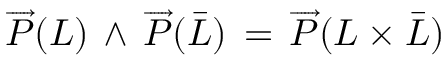<formula> <loc_0><loc_0><loc_500><loc_500>\overrightarrow { P } ( L ) \, \wedge \, \overrightarrow { P } ( \bar { L } ) \, = \, \overrightarrow { P } ( L \times \bar { L } )</formula> 